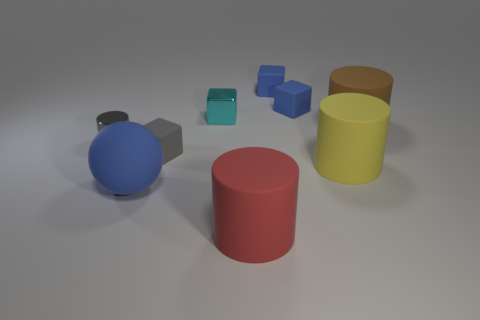Add 1 green matte cubes. How many objects exist? 10 Subtract all cubes. How many objects are left? 5 Add 9 large balls. How many large balls are left? 10 Add 1 small blue metal spheres. How many small blue metal spheres exist? 1 Subtract 0 red cubes. How many objects are left? 9 Subtract all green rubber cylinders. Subtract all yellow rubber cylinders. How many objects are left? 8 